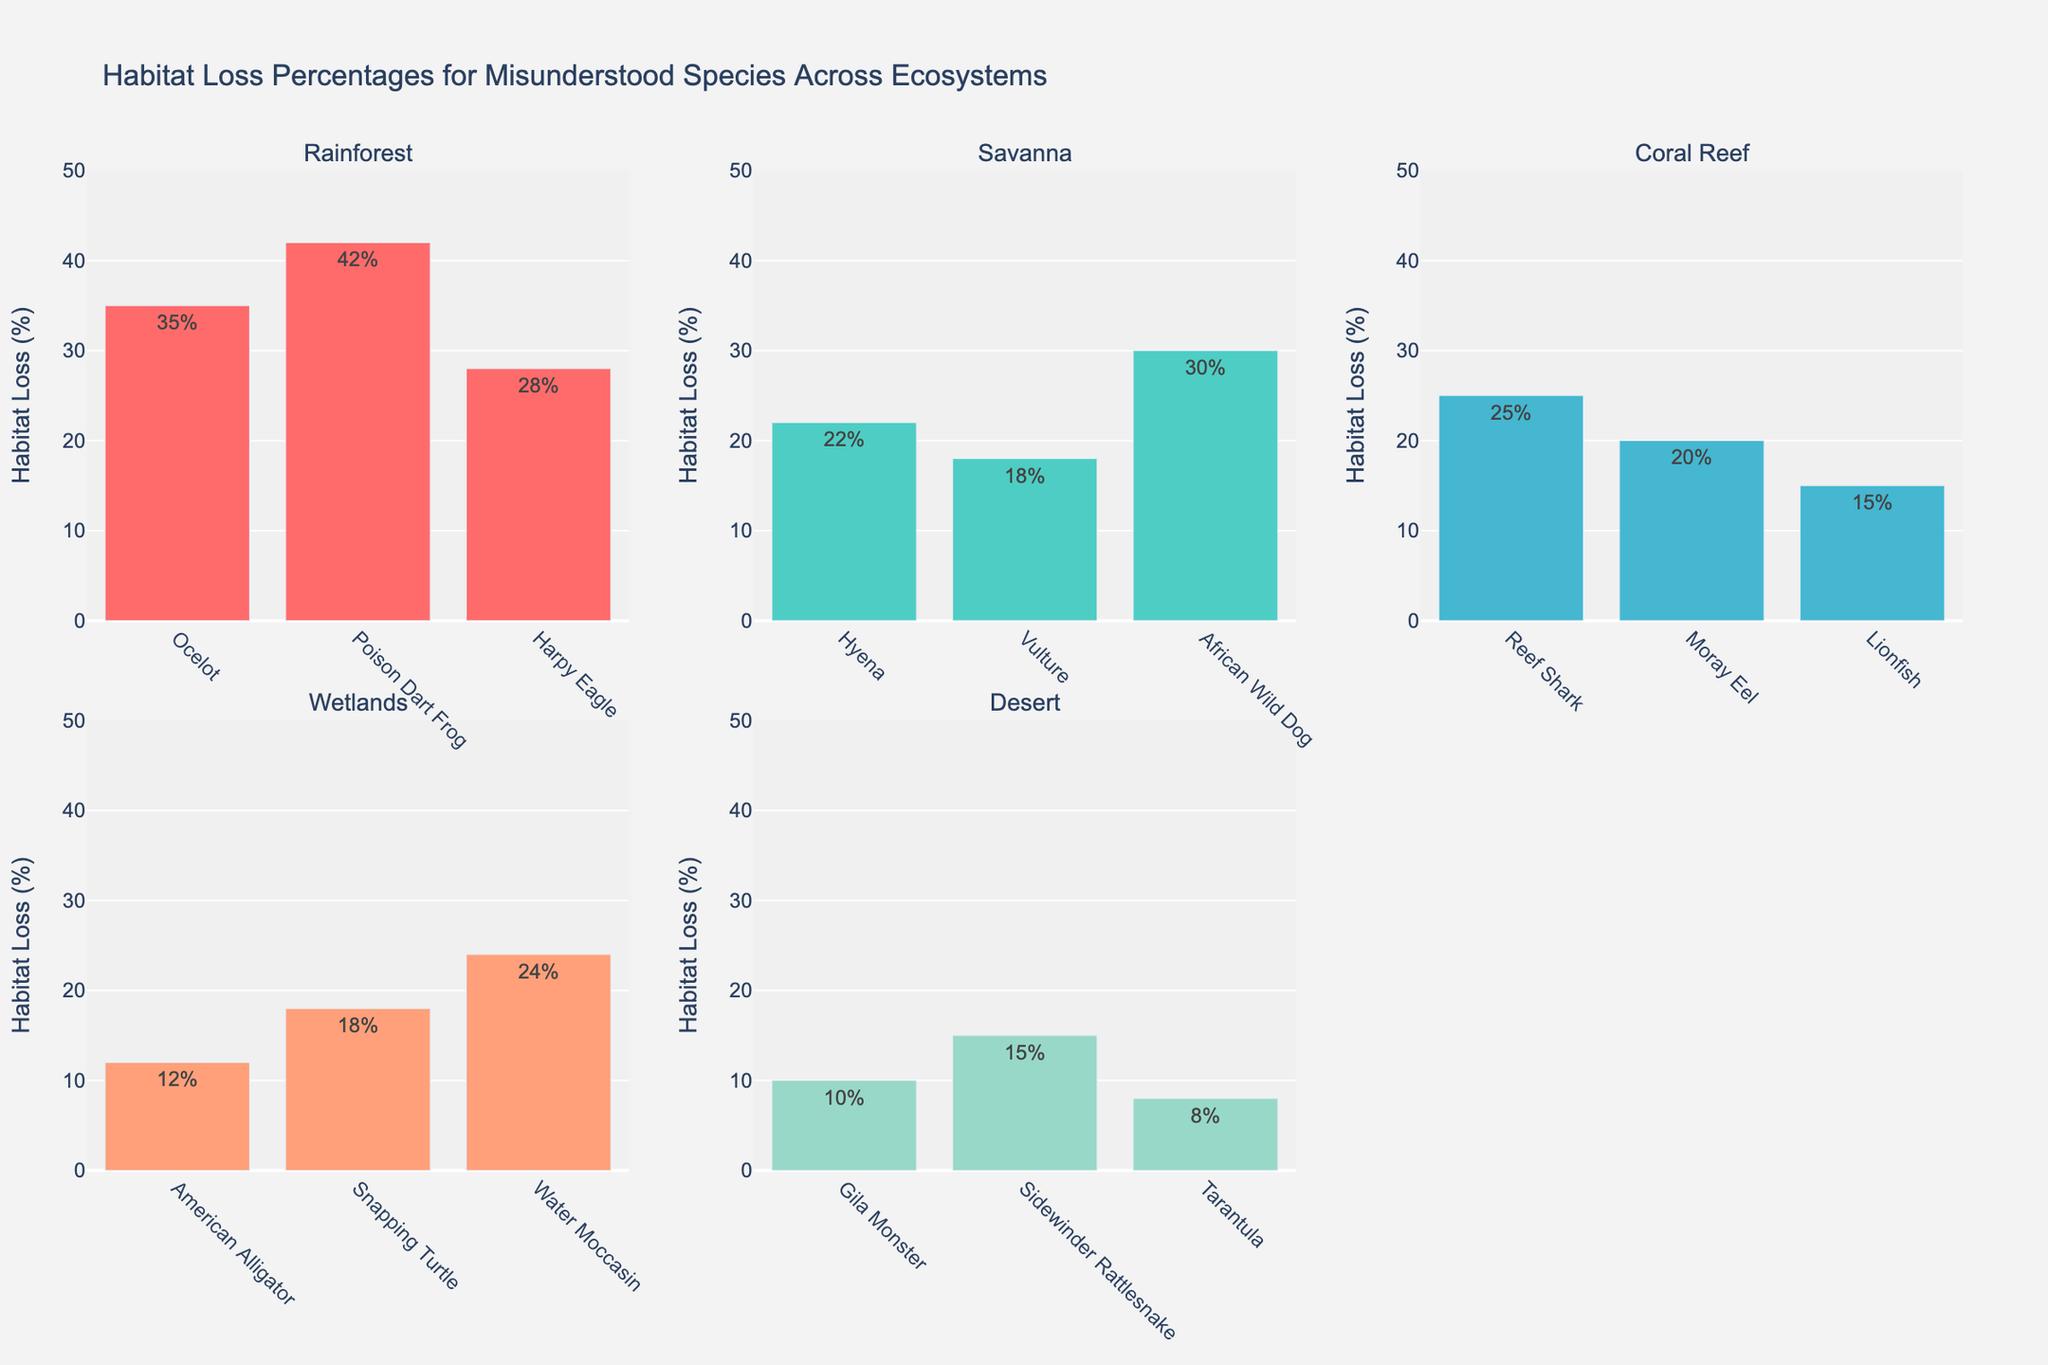What's the habitat loss percentage for the Poison Dart Frog in the Rainforest? To answer this, look at the Rainforest subplot. The bar for the Poison Dart Frog shows a habitat loss of 42%.
Answer: 42% Which species has the highest habitat loss percentage in the Coral Reef ecosystem? In the Coral Reef subplot, compare the height of the bars. The Reef Shark has the highest habitat loss percentage at 25%.
Answer: Reef Shark What is the sum of habitat loss percentages for species in the Wetlands? Add up the habitat loss percentages for the American Alligator, Snapping Turtle, and Water Moccasin from the Wetlands subplot: 12% + 18% + 24% = 54%.
Answer: 54% What's the average habitat loss percentage for the species in the Desert ecosystem? Sum the habitat loss percentages for the Desert species (Gila Monster, Sidewinder Rattlesnake, Tarantula) and divide by the number of species: (10% + 15% + 8%) / 3 = 33% / 3 = 11%.
Answer: 11% Which ecosystem has the lowest habitat loss percentage for any of its species? Compare the lowest bars in each subplot. The Desert ecosystem has the lowest habitat loss percentage for the Tarantula, which is 8%.
Answer: Desert What's the difference in habitat loss percentage between the Hyena and the African Wild Dog in the Savanna? In the Savanna subplot, subtract the habitat loss percentage of the Hyena from that of the African Wild Dog: 30% - 22% = 8%.
Answer: 8% How many species have a habitat loss percentage higher than 20%? Count the number of bars exceeding the 20% mark from all subplots: Ocelot, Poison Dart Frog, Harpy Eagle, African Wild Dog, Reef Shark, Water Moccasin. There are 6 species in total.
Answer: 6 Which ecosystem exhibits the most varied habitat loss percentages among its species? To determine this, observe the range of habitat loss percentages within each ecosystem. The Rainforest has habitat loss percentages ranging from 28% to 42% (a difference of 14%), the most varied among the rest.
Answer: Rainforest What is the habitat loss percentage for the Lionfish, and how does it compare to that of the Harpy Eagle? In the Coral Reef subplot, the Lionfish has a habitat loss of 15%. In the Rainforest subplot, the Harpy Eagle has a habitat loss of 28%. Subtract the smaller percentage from the larger: 28% - 15% = 13%.
Answer: 13% What's the highest and lowest habitat loss percentages observed in any of the ecosystems? Identify the highest bar in the entire figure and the lowest bar in the entire figure. The Poison Dart Frog in the Rainforest has the highest habitat loss percentage at 42%, and the Tarantula in the Desert has the lowest at 8%.
Answer: 42% and 8% 